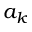Convert formula to latex. <formula><loc_0><loc_0><loc_500><loc_500>a _ { k }</formula> 